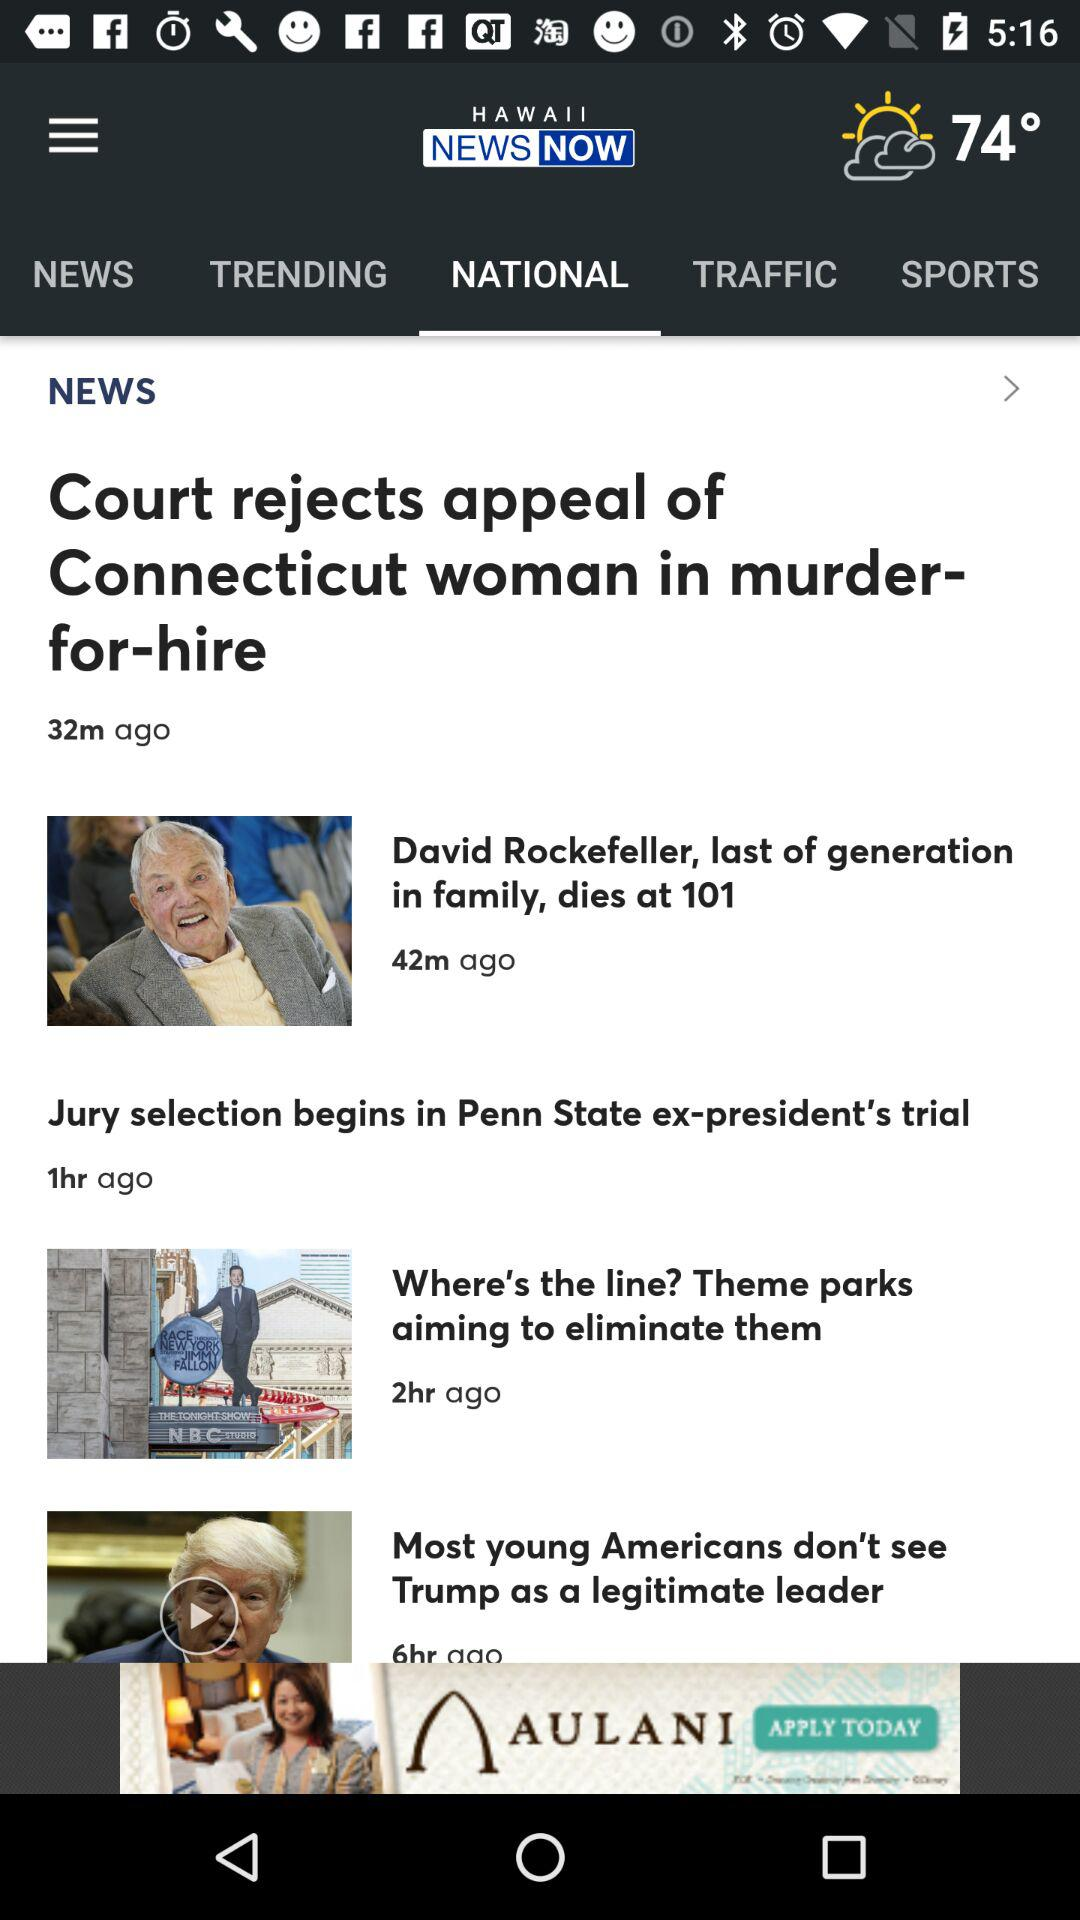What is the temperature? The temperature is 74 degrees. 